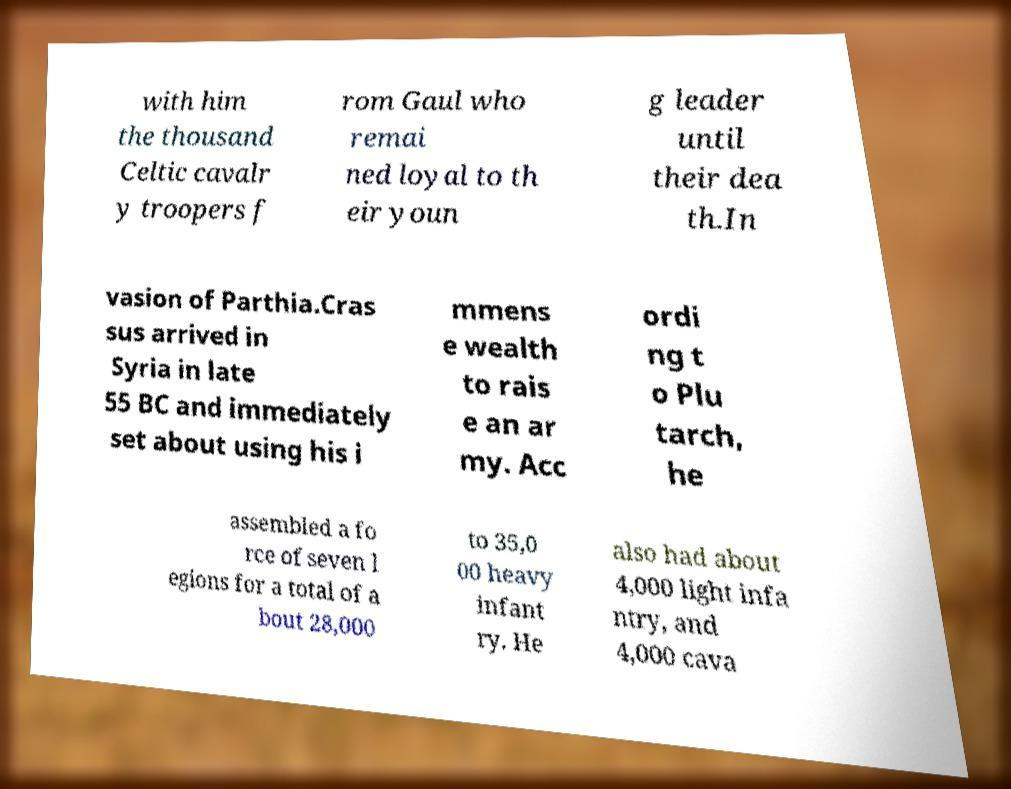Could you extract and type out the text from this image? with him the thousand Celtic cavalr y troopers f rom Gaul who remai ned loyal to th eir youn g leader until their dea th.In vasion of Parthia.Cras sus arrived in Syria in late 55 BC and immediately set about using his i mmens e wealth to rais e an ar my. Acc ordi ng t o Plu tarch, he assembled a fo rce of seven l egions for a total of a bout 28,000 to 35,0 00 heavy infant ry. He also had about 4,000 light infa ntry, and 4,000 cava 